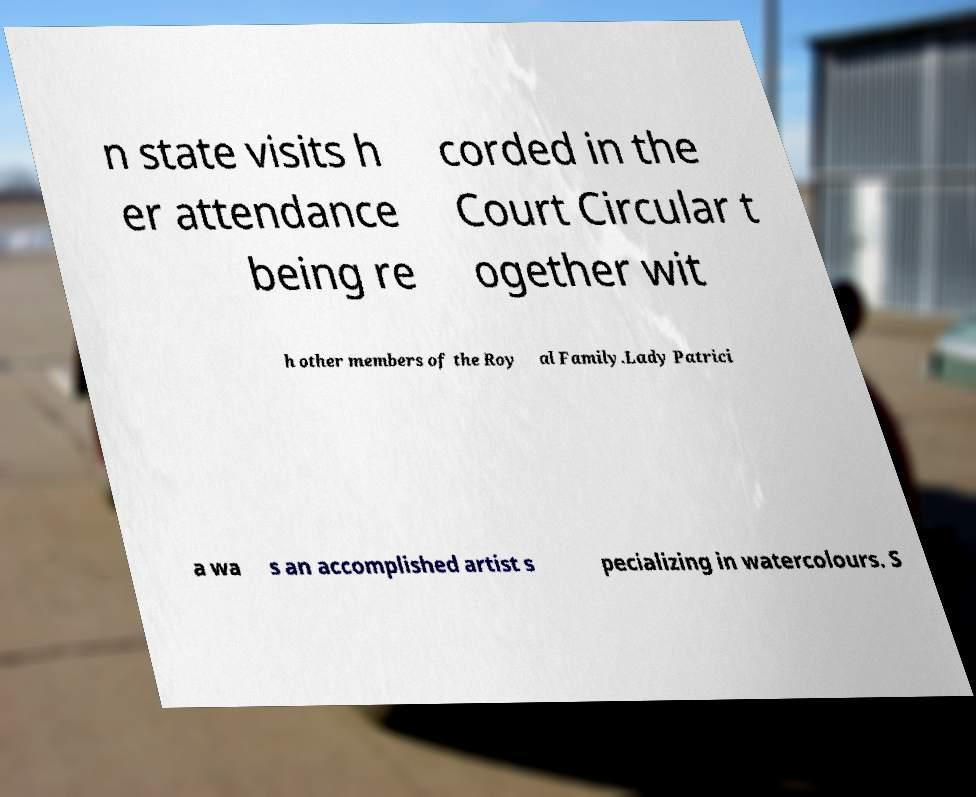There's text embedded in this image that I need extracted. Can you transcribe it verbatim? n state visits h er attendance being re corded in the Court Circular t ogether wit h other members of the Roy al Family.Lady Patrici a wa s an accomplished artist s pecializing in watercolours. S 